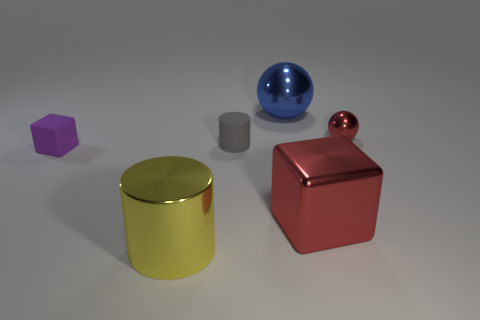Add 2 large blue metallic cylinders. How many objects exist? 8 Subtract 0 cyan cubes. How many objects are left? 6 Subtract all purple rubber blocks. Subtract all small purple cubes. How many objects are left? 4 Add 5 tiny purple things. How many tiny purple things are left? 6 Add 4 small shiny balls. How many small shiny balls exist? 5 